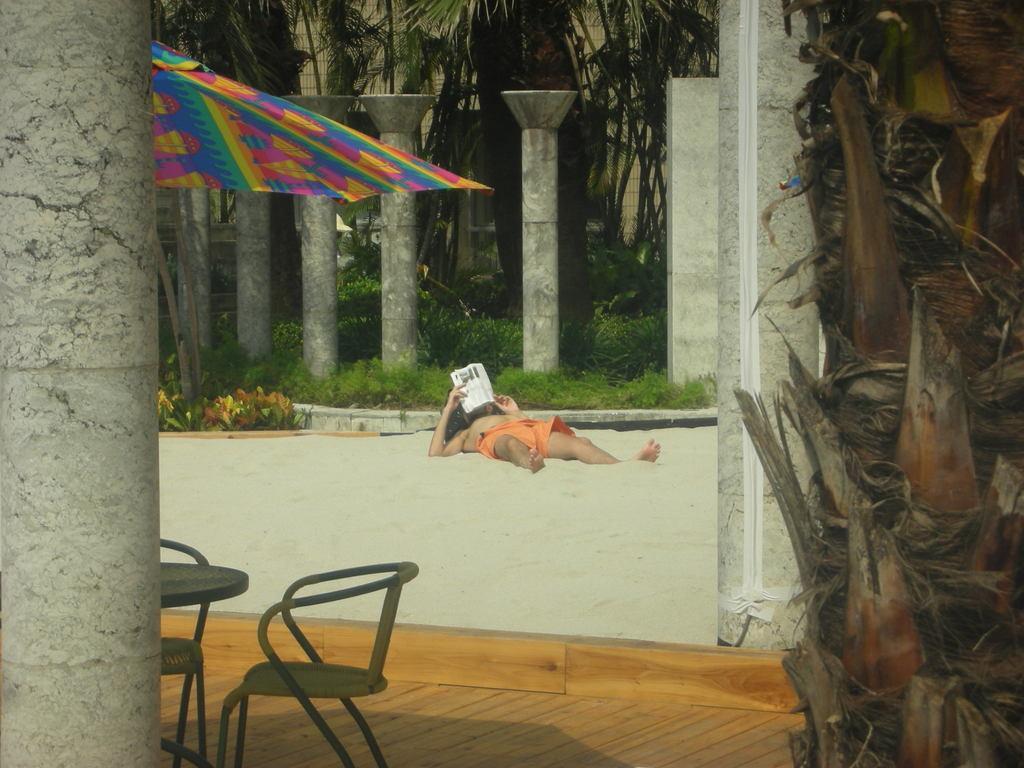Please provide a concise description of this image. This is a picture taken in the outdoor, a man is lying on the sand and holding a book. In front of the man there is a floor which is covered with wood on the floor there is a chair, table, umbrella. Background of this people is a pillar and trees. 